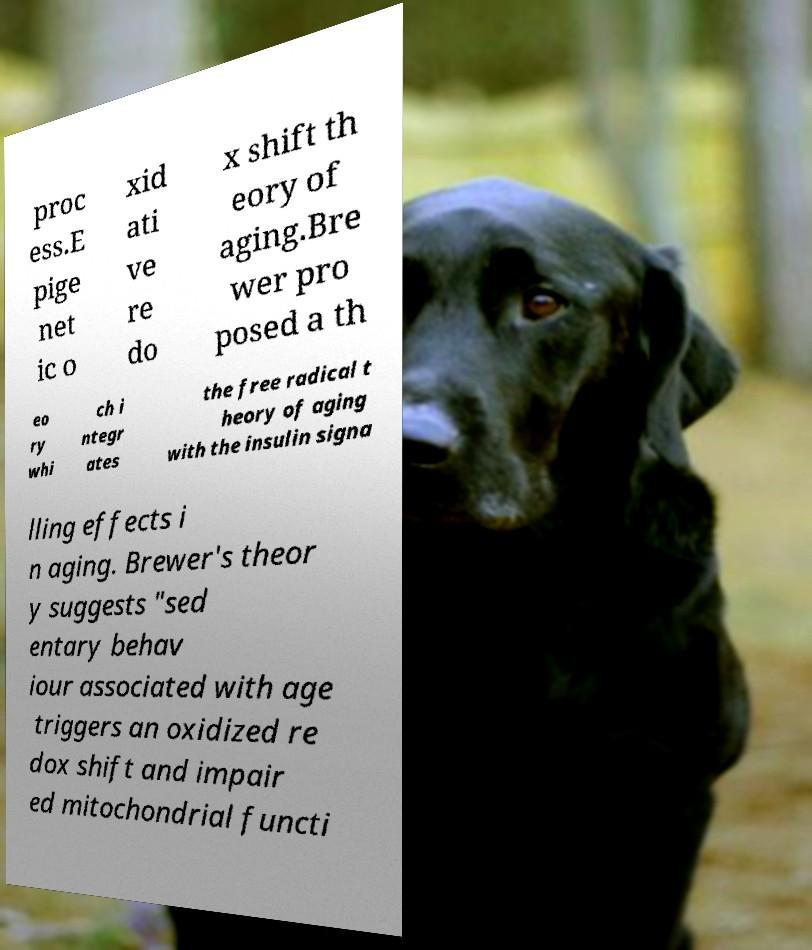I need the written content from this picture converted into text. Can you do that? proc ess.E pige net ic o xid ati ve re do x shift th eory of aging.Bre wer pro posed a th eo ry whi ch i ntegr ates the free radical t heory of aging with the insulin signa lling effects i n aging. Brewer's theor y suggests "sed entary behav iour associated with age triggers an oxidized re dox shift and impair ed mitochondrial functi 